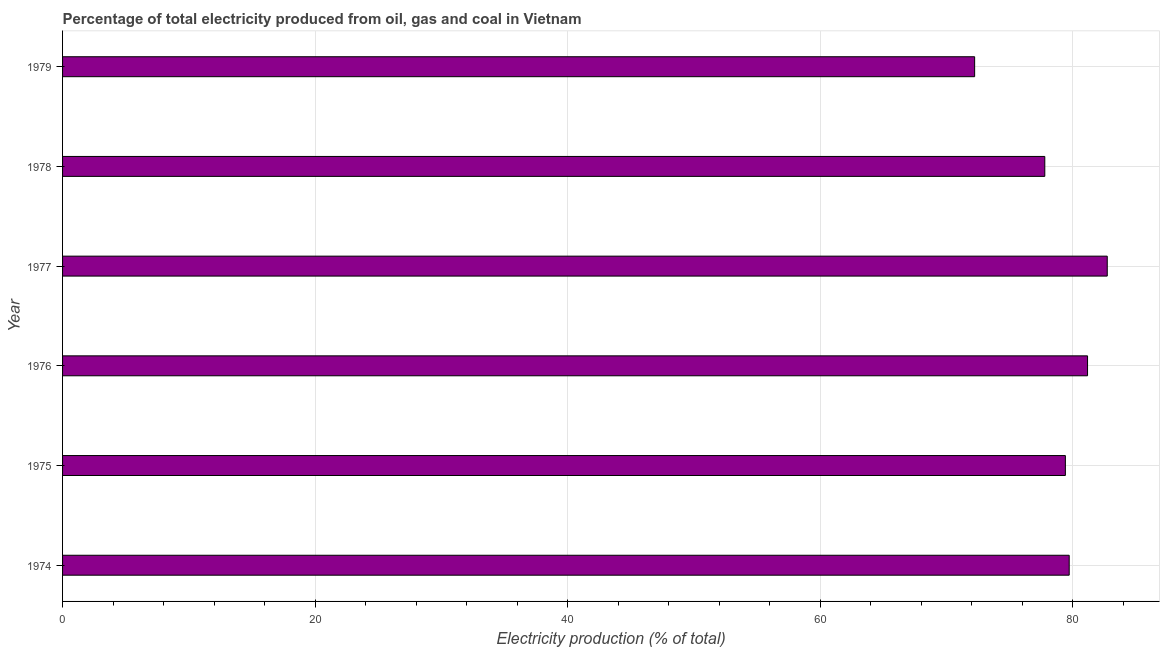Does the graph contain any zero values?
Your answer should be compact. No. Does the graph contain grids?
Provide a succinct answer. Yes. What is the title of the graph?
Offer a very short reply. Percentage of total electricity produced from oil, gas and coal in Vietnam. What is the label or title of the X-axis?
Ensure brevity in your answer.  Electricity production (% of total). What is the label or title of the Y-axis?
Ensure brevity in your answer.  Year. What is the electricity production in 1979?
Give a very brief answer. 72.22. Across all years, what is the maximum electricity production?
Ensure brevity in your answer.  82.72. Across all years, what is the minimum electricity production?
Provide a short and direct response. 72.22. In which year was the electricity production maximum?
Offer a terse response. 1977. In which year was the electricity production minimum?
Keep it short and to the point. 1979. What is the sum of the electricity production?
Provide a short and direct response. 473. What is the difference between the electricity production in 1974 and 1978?
Make the answer very short. 1.93. What is the average electricity production per year?
Keep it short and to the point. 78.83. What is the median electricity production?
Your answer should be very brief. 79.56. In how many years, is the electricity production greater than 76 %?
Your response must be concise. 5. Do a majority of the years between 1977 and 1978 (inclusive) have electricity production greater than 64 %?
Your answer should be very brief. Yes. What is the ratio of the electricity production in 1976 to that in 1979?
Provide a short and direct response. 1.12. Is the electricity production in 1974 less than that in 1978?
Your answer should be very brief. No. Is the difference between the electricity production in 1978 and 1979 greater than the difference between any two years?
Your response must be concise. No. What is the difference between the highest and the second highest electricity production?
Keep it short and to the point. 1.56. Is the sum of the electricity production in 1974 and 1978 greater than the maximum electricity production across all years?
Give a very brief answer. Yes. What is the difference between the highest and the lowest electricity production?
Keep it short and to the point. 10.5. What is the Electricity production (% of total) of 1974?
Offer a very short reply. 79.71. What is the Electricity production (% of total) in 1975?
Keep it short and to the point. 79.41. What is the Electricity production (% of total) in 1976?
Provide a succinct answer. 81.16. What is the Electricity production (% of total) in 1977?
Ensure brevity in your answer.  82.72. What is the Electricity production (% of total) in 1978?
Provide a succinct answer. 77.78. What is the Electricity production (% of total) of 1979?
Your response must be concise. 72.22. What is the difference between the Electricity production (% of total) in 1974 and 1975?
Make the answer very short. 0.3. What is the difference between the Electricity production (% of total) in 1974 and 1976?
Provide a succinct answer. -1.45. What is the difference between the Electricity production (% of total) in 1974 and 1977?
Keep it short and to the point. -3.01. What is the difference between the Electricity production (% of total) in 1974 and 1978?
Provide a succinct answer. 1.93. What is the difference between the Electricity production (% of total) in 1974 and 1979?
Keep it short and to the point. 7.49. What is the difference between the Electricity production (% of total) in 1975 and 1976?
Ensure brevity in your answer.  -1.76. What is the difference between the Electricity production (% of total) in 1975 and 1977?
Provide a succinct answer. -3.32. What is the difference between the Electricity production (% of total) in 1975 and 1978?
Make the answer very short. 1.63. What is the difference between the Electricity production (% of total) in 1975 and 1979?
Ensure brevity in your answer.  7.18. What is the difference between the Electricity production (% of total) in 1976 and 1977?
Offer a terse response. -1.56. What is the difference between the Electricity production (% of total) in 1976 and 1978?
Offer a very short reply. 3.39. What is the difference between the Electricity production (% of total) in 1976 and 1979?
Ensure brevity in your answer.  8.94. What is the difference between the Electricity production (% of total) in 1977 and 1978?
Ensure brevity in your answer.  4.95. What is the difference between the Electricity production (% of total) in 1977 and 1979?
Give a very brief answer. 10.5. What is the difference between the Electricity production (% of total) in 1978 and 1979?
Keep it short and to the point. 5.56. What is the ratio of the Electricity production (% of total) in 1974 to that in 1977?
Offer a very short reply. 0.96. What is the ratio of the Electricity production (% of total) in 1974 to that in 1978?
Keep it short and to the point. 1.02. What is the ratio of the Electricity production (% of total) in 1974 to that in 1979?
Your answer should be compact. 1.1. What is the ratio of the Electricity production (% of total) in 1975 to that in 1976?
Your answer should be compact. 0.98. What is the ratio of the Electricity production (% of total) in 1975 to that in 1977?
Give a very brief answer. 0.96. What is the ratio of the Electricity production (% of total) in 1975 to that in 1978?
Offer a terse response. 1.02. What is the ratio of the Electricity production (% of total) in 1975 to that in 1979?
Provide a short and direct response. 1.1. What is the ratio of the Electricity production (% of total) in 1976 to that in 1977?
Make the answer very short. 0.98. What is the ratio of the Electricity production (% of total) in 1976 to that in 1978?
Your response must be concise. 1.04. What is the ratio of the Electricity production (% of total) in 1976 to that in 1979?
Your answer should be compact. 1.12. What is the ratio of the Electricity production (% of total) in 1977 to that in 1978?
Keep it short and to the point. 1.06. What is the ratio of the Electricity production (% of total) in 1977 to that in 1979?
Provide a short and direct response. 1.15. What is the ratio of the Electricity production (% of total) in 1978 to that in 1979?
Give a very brief answer. 1.08. 